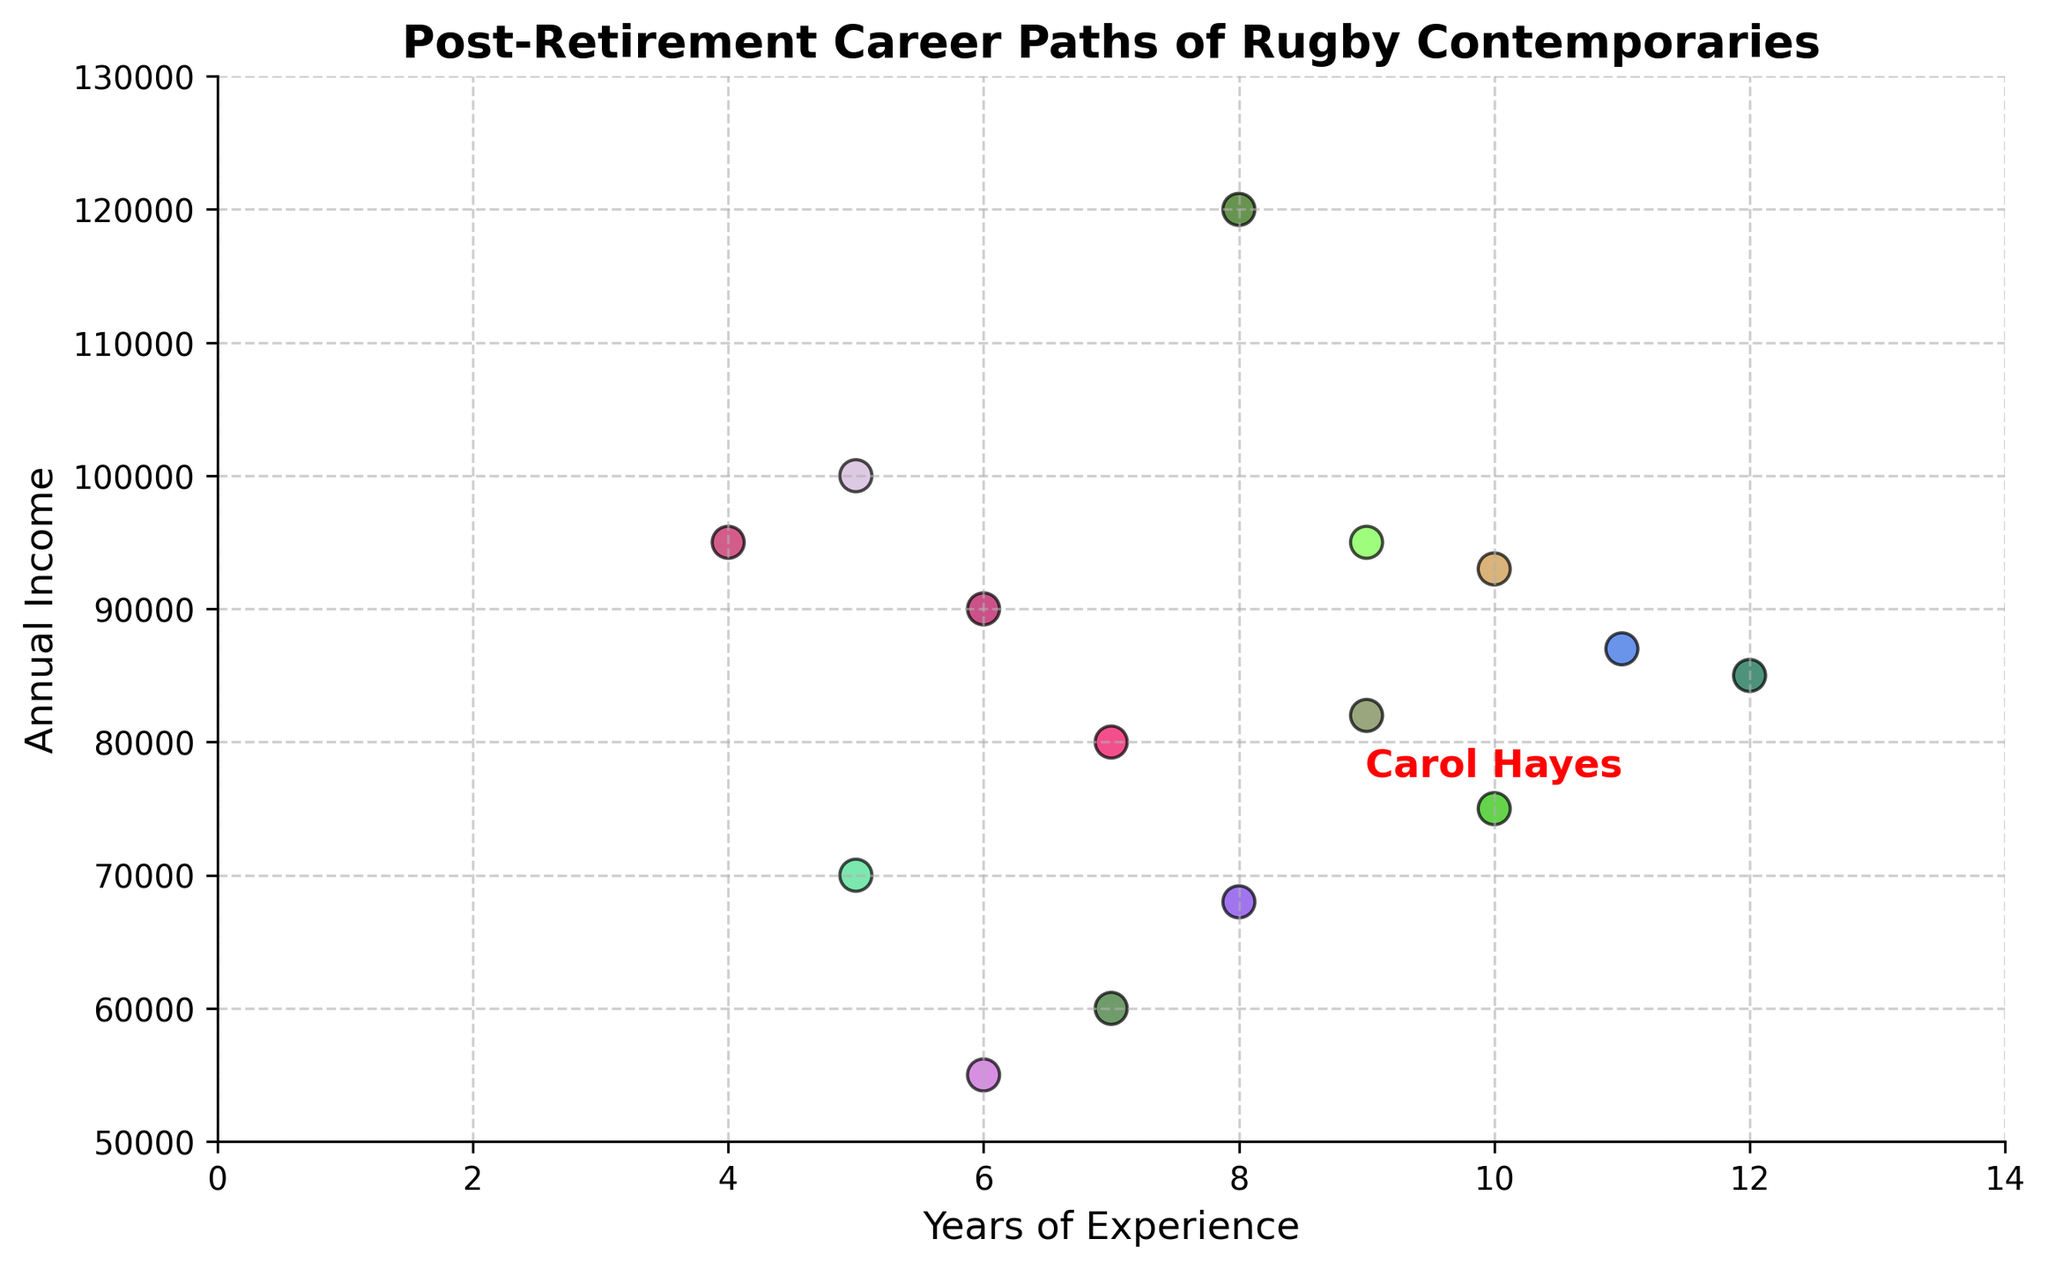What is the annual income of Carol Hayes? Carol Hayes is explicitly annotated in the plot, and her income is marked near the point corresponding to her experience and income values.
Answer: 75,000 Who among the rugby contemporaries has the highest annual income based on the scatter plot? By examining the scatter plot, the point located the highest on the y-axis corresponds to Sarah Black in Financial Services with 100,000 annual income.
Answer: Sarah Black What are the industries represented by the rugby contemporaries with more than 10 years of experience? Identify the points which have more than 10 years of experience on the x-axis. These are Jake Brown (Healthcare) and Michael Young (Engineering).
Answer: Healthcare, Engineering How many individuals have an annual income greater than 90,000? Count the points that lie above the 90,000 mark on the y-axis. This includes Jane Smith (Business Consulting), Chris Green (Real Estate), Sarah Black (Financial Services), Laura King (Technology), and Rebecca Turner (Law).
Answer: 5 Which industry does the individual with the shortest years of experience (4 years) work in? Locate the point closest to 4 years on the x-axis. This corresponds to Laura King in the Technology industry.
Answer: Technology Compare the annual income of individuals with the same years of experience as Carol Hayes. How does she rank among them? Carol Hayes has 10 years of experience. Compare her income with others with the same experience. Carol Hayes (75,000), Stephen Ward (93,000). Carol Hayes has a lower income than Stephen Ward.
Answer: Second What is the total combined annual income of individuals whose industries fall under 'Consulting'? Identify individuals in consulting-related industries: Jane Smith (Business Consulting: 90,000), Carol Hayes (Coaching: 75,000). Sum their incomes. 90,000 + 75,000 = 165,000.
Answer: 165,000 Which industry has the largest spread in annual income among its representatives? Evaluate the range of annual incomes in each industry by comparing the maximum and minimum incomes where industries are represented multiple times. For this plot, the closest one to spread is Consulting where the minimum is 75,000 (Carol Hayes) and maximum is 90,000 (Jane Smith). But, it appears industry spread in a general sense isn’t immediately resolvable without further categorization, focusing just on Consulting presented diversely spread ok.
Answer: Consulting What is the ratio of maximum income to minimum annual income among all rugby contemporaries shown in the plot? Identify the maximum income (Rebecca Turner: 120,000) and minimum income (Amy Lewis: 55,000) and calculate the ratio. 120,000 / 55,000 = approximately 2.18.
Answer: 2.18 Which individual in the Education industry has the same experience as Carol Hayes, and what is their annual income? Look for the individual in the Education industry and compare years of experience to Carol Hayes. Emily White in Education has 7 years of experience and income of 60,000. No same experienced person.
Answer: None 